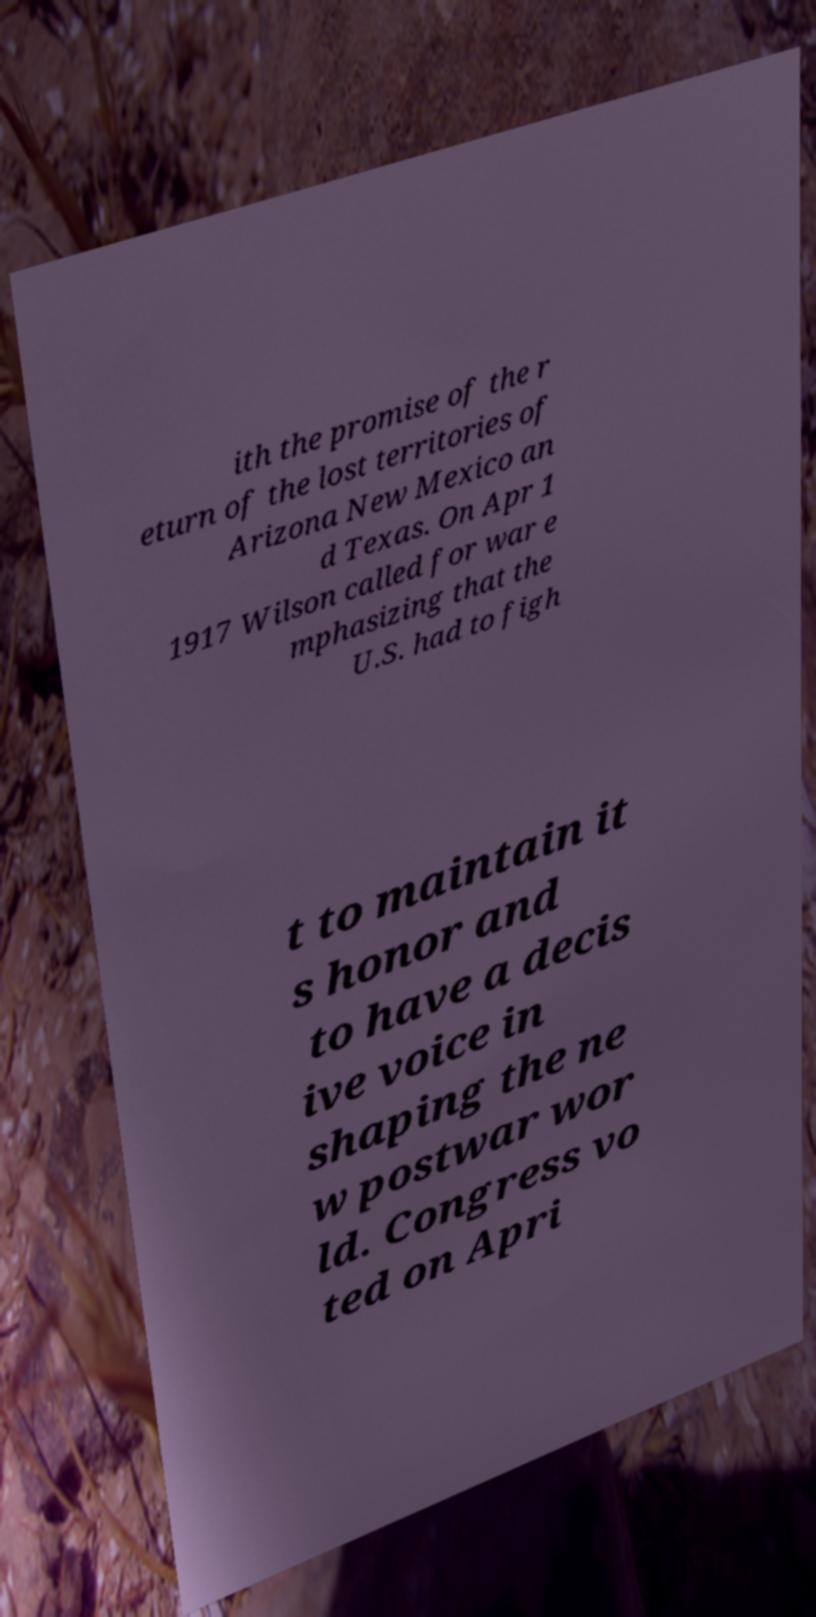Please identify and transcribe the text found in this image. ith the promise of the r eturn of the lost territories of Arizona New Mexico an d Texas. On Apr 1 1917 Wilson called for war e mphasizing that the U.S. had to figh t to maintain it s honor and to have a decis ive voice in shaping the ne w postwar wor ld. Congress vo ted on Apri 